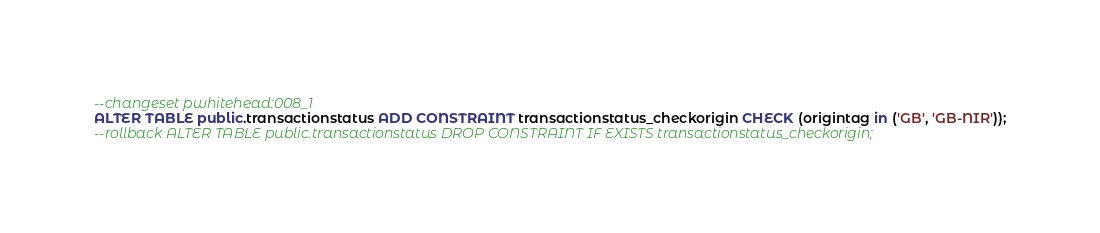Convert code to text. <code><loc_0><loc_0><loc_500><loc_500><_SQL_>--changeset pwhitehead:008_1
ALTER TABLE public.transactionstatus ADD CONSTRAINT transactionstatus_checkorigin CHECK (origintag in ('GB', 'GB-NIR'));
--rollback ALTER TABLE public.transactionstatus DROP CONSTRAINT IF EXISTS transactionstatus_checkorigin;
</code> 